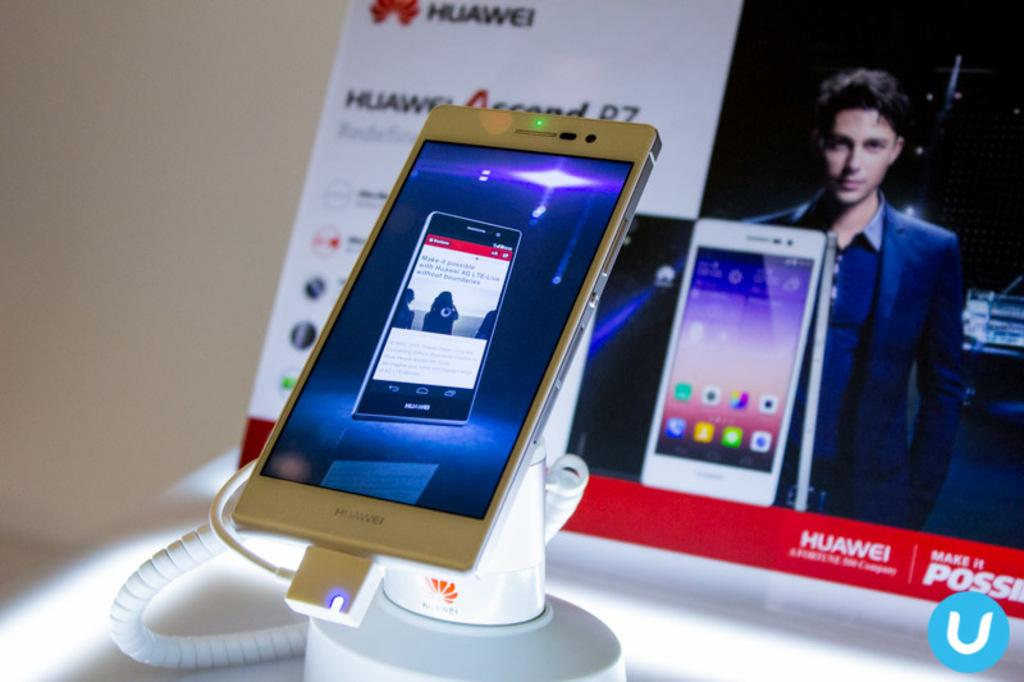<image>
Write a terse but informative summary of the picture. a phone that says Huawei at the bottom 